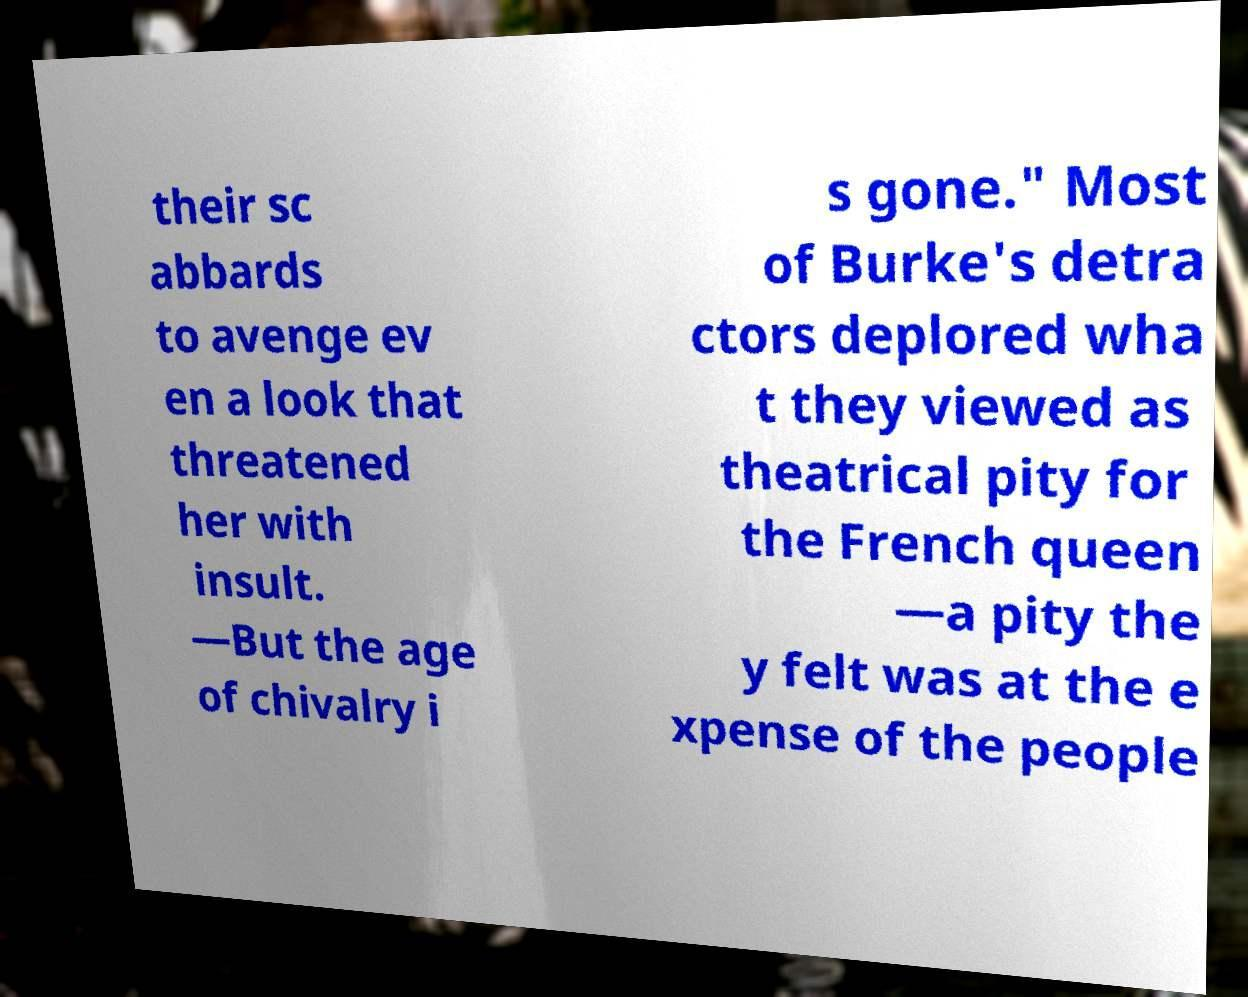Can you read and provide the text displayed in the image?This photo seems to have some interesting text. Can you extract and type it out for me? their sc abbards to avenge ev en a look that threatened her with insult. —But the age of chivalry i s gone." Most of Burke's detra ctors deplored wha t they viewed as theatrical pity for the French queen —a pity the y felt was at the e xpense of the people 